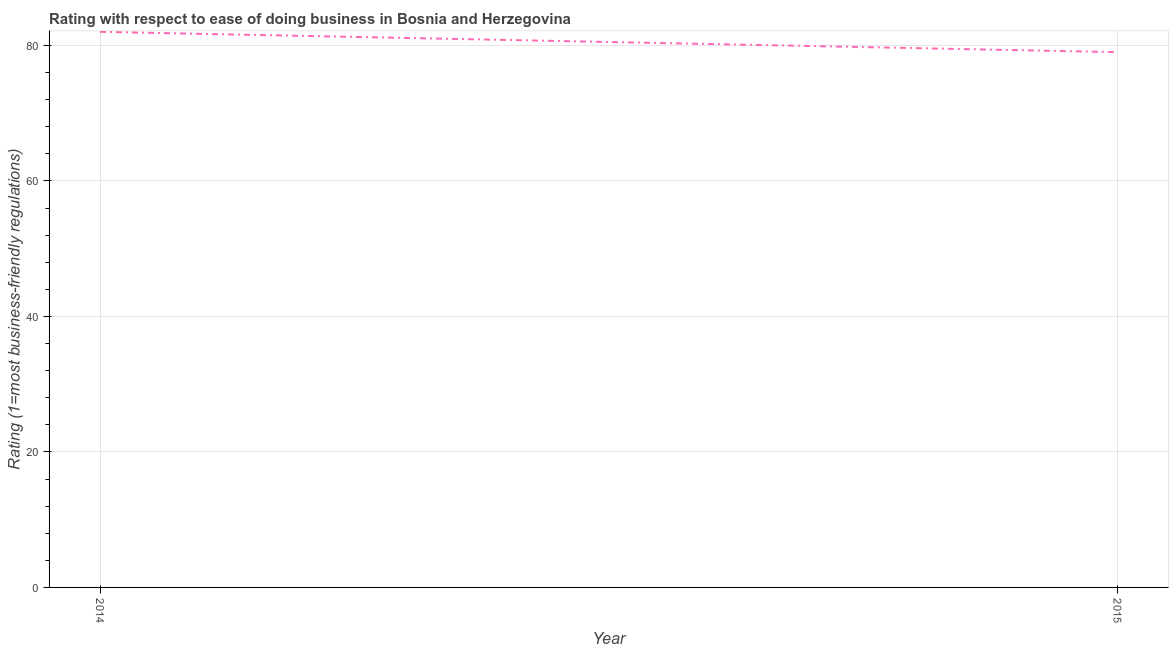What is the ease of doing business index in 2015?
Offer a terse response. 79. Across all years, what is the maximum ease of doing business index?
Your answer should be very brief. 82. Across all years, what is the minimum ease of doing business index?
Offer a very short reply. 79. In which year was the ease of doing business index maximum?
Offer a terse response. 2014. In which year was the ease of doing business index minimum?
Provide a short and direct response. 2015. What is the sum of the ease of doing business index?
Provide a succinct answer. 161. What is the difference between the ease of doing business index in 2014 and 2015?
Provide a succinct answer. 3. What is the average ease of doing business index per year?
Your response must be concise. 80.5. What is the median ease of doing business index?
Offer a very short reply. 80.5. In how many years, is the ease of doing business index greater than 24 ?
Your answer should be compact. 2. Do a majority of the years between 2015 and 2014 (inclusive) have ease of doing business index greater than 20 ?
Keep it short and to the point. No. What is the ratio of the ease of doing business index in 2014 to that in 2015?
Offer a terse response. 1.04. In how many years, is the ease of doing business index greater than the average ease of doing business index taken over all years?
Give a very brief answer. 1. How many lines are there?
Provide a short and direct response. 1. What is the difference between two consecutive major ticks on the Y-axis?
Offer a terse response. 20. What is the title of the graph?
Keep it short and to the point. Rating with respect to ease of doing business in Bosnia and Herzegovina. What is the label or title of the X-axis?
Offer a terse response. Year. What is the label or title of the Y-axis?
Make the answer very short. Rating (1=most business-friendly regulations). What is the Rating (1=most business-friendly regulations) of 2015?
Keep it short and to the point. 79. What is the ratio of the Rating (1=most business-friendly regulations) in 2014 to that in 2015?
Provide a short and direct response. 1.04. 